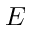<formula> <loc_0><loc_0><loc_500><loc_500>E</formula> 